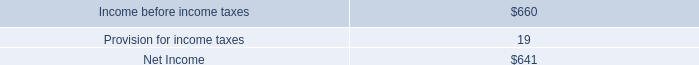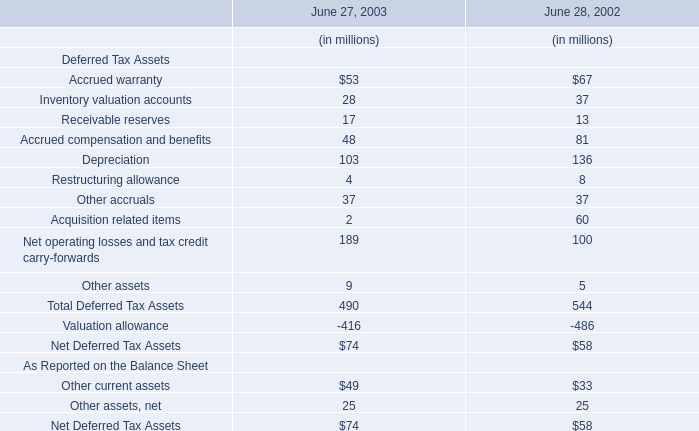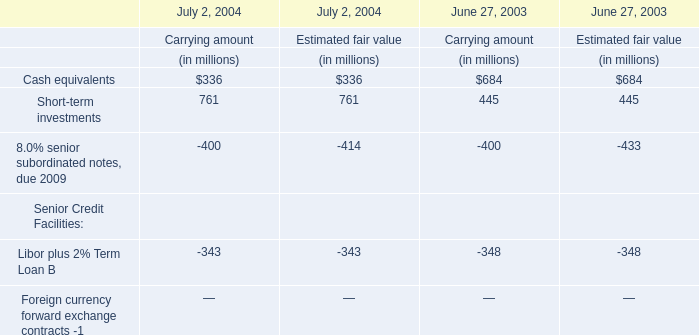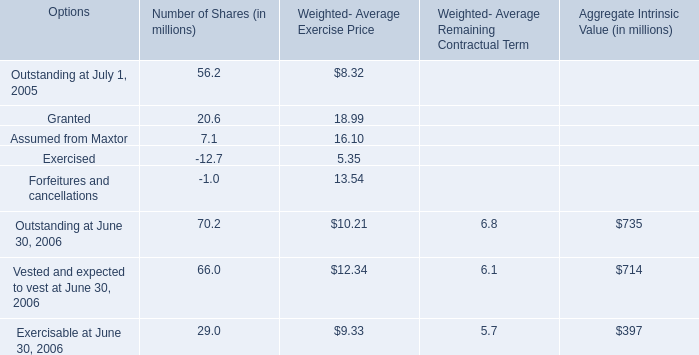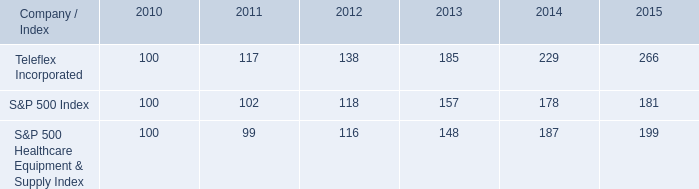What is the proportion of all Number of Shares that are greater than 0 to the total amount of Number of Shares, in 2005? 
Computations: (((56.2 + 20.6) + 7.1) / ((((56.2 + 20.6) + 7.1) - 12.7) - 1.0))
Answer: 1.19516. 